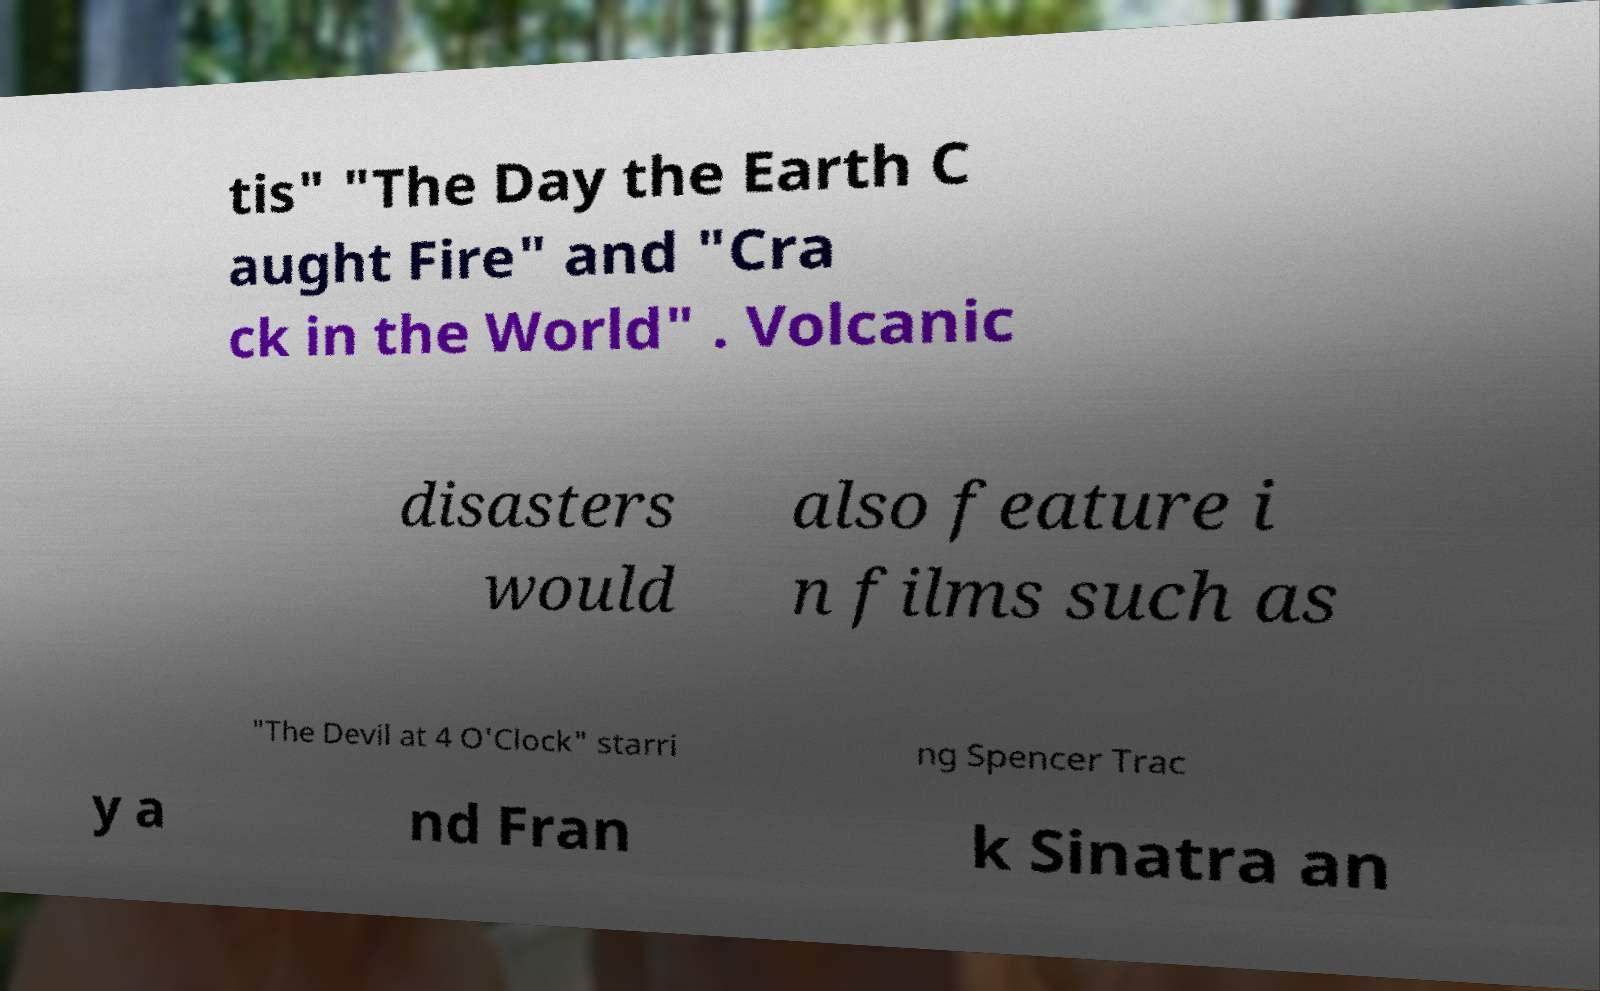There's text embedded in this image that I need extracted. Can you transcribe it verbatim? tis" "The Day the Earth C aught Fire" and "Cra ck in the World" . Volcanic disasters would also feature i n films such as "The Devil at 4 O'Clock" starri ng Spencer Trac y a nd Fran k Sinatra an 